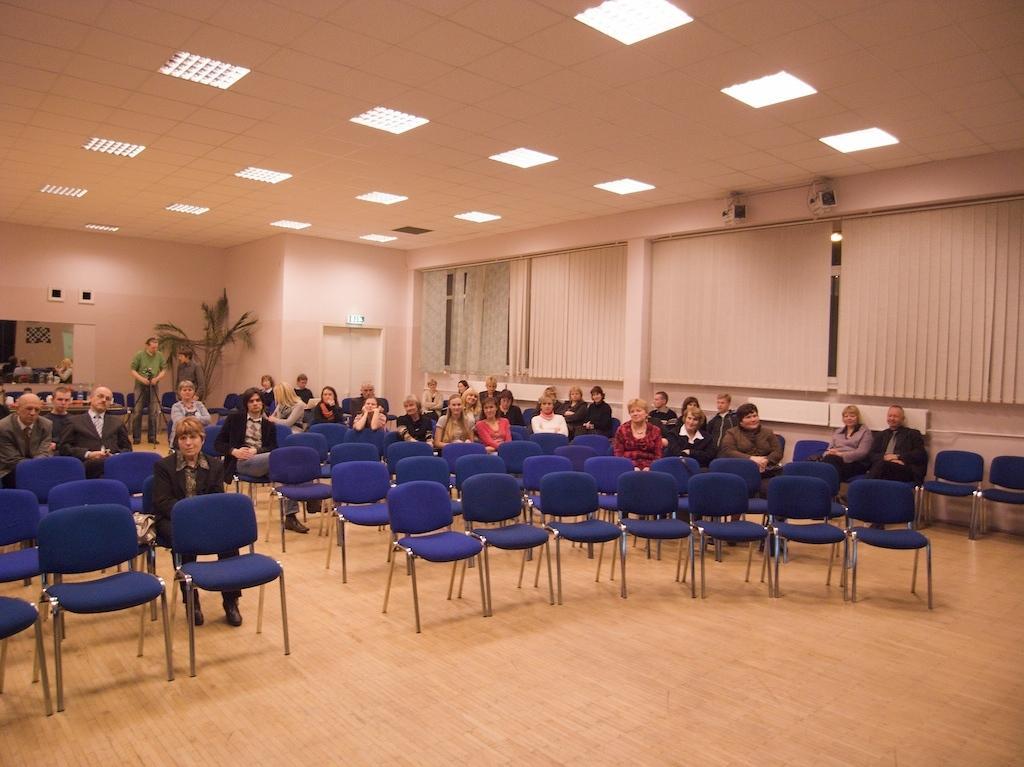How would you summarize this image in a sentence or two? This picture is inside view of a room. In the center of the image we can see chairs, some persons, plant, curtains, door, windows, light, roof, wall are there. At the bottom of the image there is a floor. 